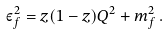<formula> <loc_0><loc_0><loc_500><loc_500>\varepsilon _ { f } ^ { 2 } = z ( 1 - z ) Q ^ { 2 } + m _ { f } ^ { 2 } \, .</formula> 